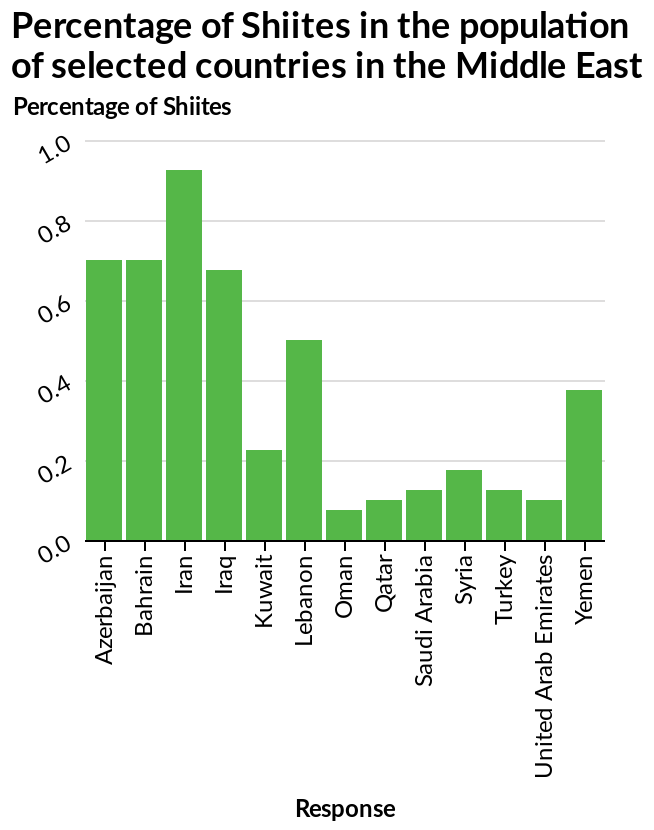<image>
please summary the statistics and relations of the chart Iran has a significantly higher percentage of shiites than any other country. How does the bar plot represent the data? The bar plot visually represents the relationship between different responses and the corresponding percentage of Shiites in the population of selected Middle Eastern countries. How many countries have a significant Shiite population?  Four countries. What is plotted on the x-axis of the bar plot?  The x-axis of the bar plot represents "Response". 